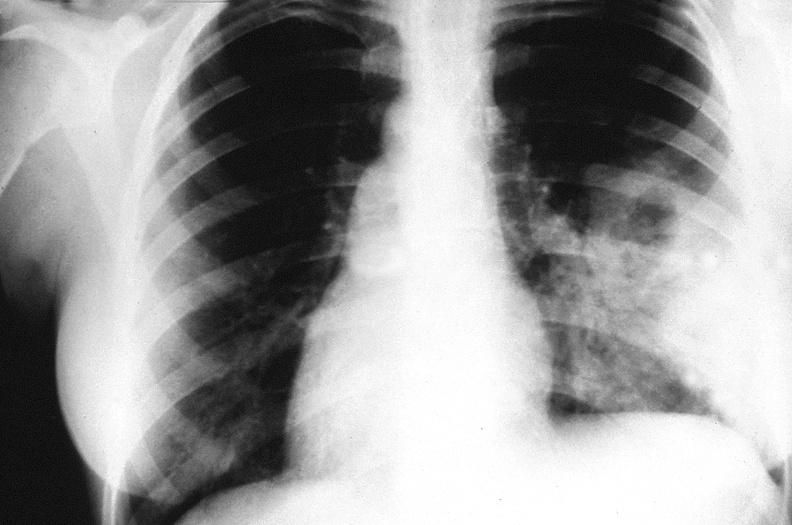s respiratory present?
Answer the question using a single word or phrase. Yes 